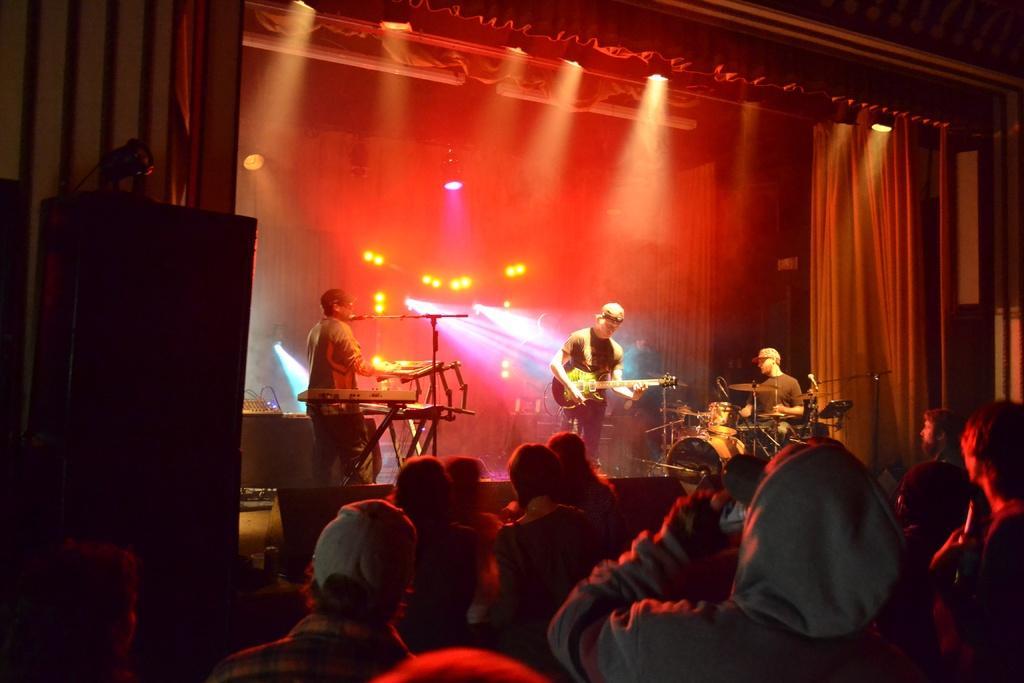Please provide a concise description of this image. In this image in the front there are persons. In the background there are musicians performing on the stage and there is a curtain and there are lights. On the left side there is an object which is black in colour. 